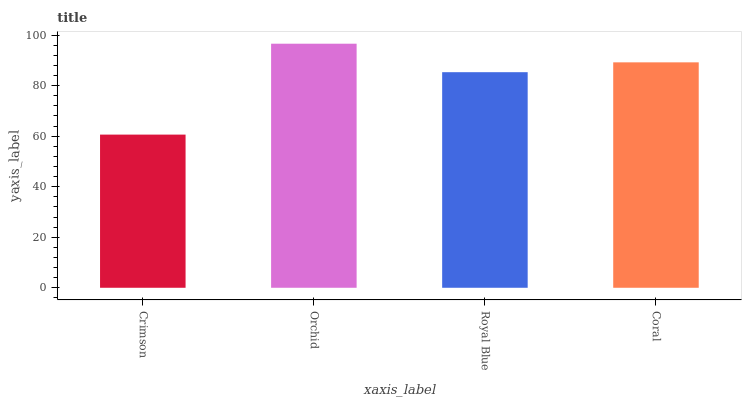Is Royal Blue the minimum?
Answer yes or no. No. Is Royal Blue the maximum?
Answer yes or no. No. Is Orchid greater than Royal Blue?
Answer yes or no. Yes. Is Royal Blue less than Orchid?
Answer yes or no. Yes. Is Royal Blue greater than Orchid?
Answer yes or no. No. Is Orchid less than Royal Blue?
Answer yes or no. No. Is Coral the high median?
Answer yes or no. Yes. Is Royal Blue the low median?
Answer yes or no. Yes. Is Royal Blue the high median?
Answer yes or no. No. Is Crimson the low median?
Answer yes or no. No. 